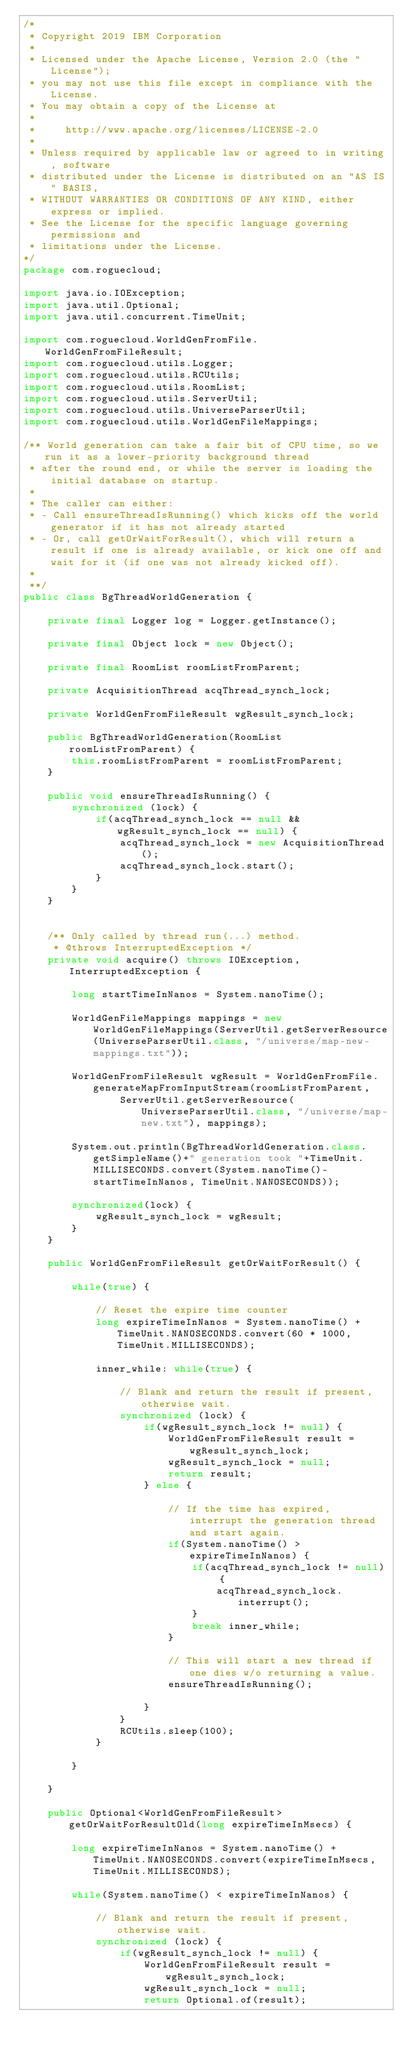Convert code to text. <code><loc_0><loc_0><loc_500><loc_500><_Java_>/*
 * Copyright 2019 IBM Corporation
 * 
 * Licensed under the Apache License, Version 2.0 (the "License");
 * you may not use this file except in compliance with the License.
 * You may obtain a copy of the License at
 *
 *     http://www.apache.org/licenses/LICENSE-2.0
 *
 * Unless required by applicable law or agreed to in writing, software
 * distributed under the License is distributed on an "AS IS" BASIS,
 * WITHOUT WARRANTIES OR CONDITIONS OF ANY KIND, either express or implied.
 * See the License for the specific language governing permissions and
 * limitations under the License. 
*/
package com.roguecloud;

import java.io.IOException;
import java.util.Optional;
import java.util.concurrent.TimeUnit;

import com.roguecloud.WorldGenFromFile.WorldGenFromFileResult;
import com.roguecloud.utils.Logger;
import com.roguecloud.utils.RCUtils;
import com.roguecloud.utils.RoomList;
import com.roguecloud.utils.ServerUtil;
import com.roguecloud.utils.UniverseParserUtil;
import com.roguecloud.utils.WorldGenFileMappings;

/** World generation can take a fair bit of CPU time, so we run it as a lower-priority background thread 
 * after the round end, or while the server is loading the initial database on startup.
 * 
 * The caller can either:
 * - Call ensureThreadIsRunning() which kicks off the world generator if it has not already started
 * - Or, call getOrWaitForResult(), which will return a result if one is already available, or kick one off and wait for it (if one was not already kicked off).
 * 
 **/
public class BgThreadWorldGeneration {
	
	private final Logger log = Logger.getInstance();
	
	private final Object lock = new Object();
	
	private final RoomList roomListFromParent;
	
	private AcquisitionThread acqThread_synch_lock;
	
	private WorldGenFromFileResult wgResult_synch_lock;
	
	public BgThreadWorldGeneration(RoomList roomListFromParent) {
		this.roomListFromParent = roomListFromParent;
	}
	
	public void ensureThreadIsRunning() {
		synchronized (lock) {
			if(acqThread_synch_lock == null && wgResult_synch_lock == null) {
				acqThread_synch_lock = new AcquisitionThread();
				acqThread_synch_lock.start();
			}
		}
	}
	

	/** Only called by thread run(...) method.
	 * @throws InterruptedException */
	private void acquire() throws IOException, InterruptedException {

		long startTimeInNanos = System.nanoTime();
		
		WorldGenFileMappings mappings = new WorldGenFileMappings(ServerUtil.getServerResource(UniverseParserUtil.class, "/universe/map-new-mappings.txt"));
		
		WorldGenFromFileResult wgResult = WorldGenFromFile.generateMapFromInputStream(roomListFromParent, 
				ServerUtil.getServerResource(UniverseParserUtil.class, "/universe/map-new.txt"), mappings);

		System.out.println(BgThreadWorldGeneration.class.getSimpleName()+" generation took "+TimeUnit.MILLISECONDS.convert(System.nanoTime()-startTimeInNanos, TimeUnit.NANOSECONDS));

		synchronized(lock) {
			wgResult_synch_lock = wgResult;
		}
	}
	
	public WorldGenFromFileResult getOrWaitForResult() {
		
		while(true) {
			
			// Reset the expire time counter 
			long expireTimeInNanos = System.nanoTime() + TimeUnit.NANOSECONDS.convert(60 * 1000, TimeUnit.MILLISECONDS); 
			
			inner_while: while(true) {
				
				// Blank and return the result if present, otherwise wait.
				synchronized (lock) {
					if(wgResult_synch_lock != null) {
						WorldGenFromFileResult result = wgResult_synch_lock;
						wgResult_synch_lock = null;
						return result;
					} else {
						
						// If the time has expired, interrupt the generation thread and start again.
						if(System.nanoTime() > expireTimeInNanos) {
							if(acqThread_synch_lock != null) {
								acqThread_synch_lock.interrupt();
							}
							break inner_while;
						}

						// This will start a new thread if one dies w/o returning a value.
						ensureThreadIsRunning();
						
					}
				}
				RCUtils.sleep(100);
			}
			
		}
		
	}

	public Optional<WorldGenFromFileResult> getOrWaitForResultOld(long expireTimeInMsecs) {
		
		long expireTimeInNanos = System.nanoTime() + TimeUnit.NANOSECONDS.convert(expireTimeInMsecs, TimeUnit.MILLISECONDS);
		
		while(System.nanoTime() < expireTimeInNanos) {
			
			// Blank and return the result if present, otherwise wait.
			synchronized (lock) {
				if(wgResult_synch_lock != null) {
					WorldGenFromFileResult result = wgResult_synch_lock;
					wgResult_synch_lock = null;
					return Optional.of(result);</code> 